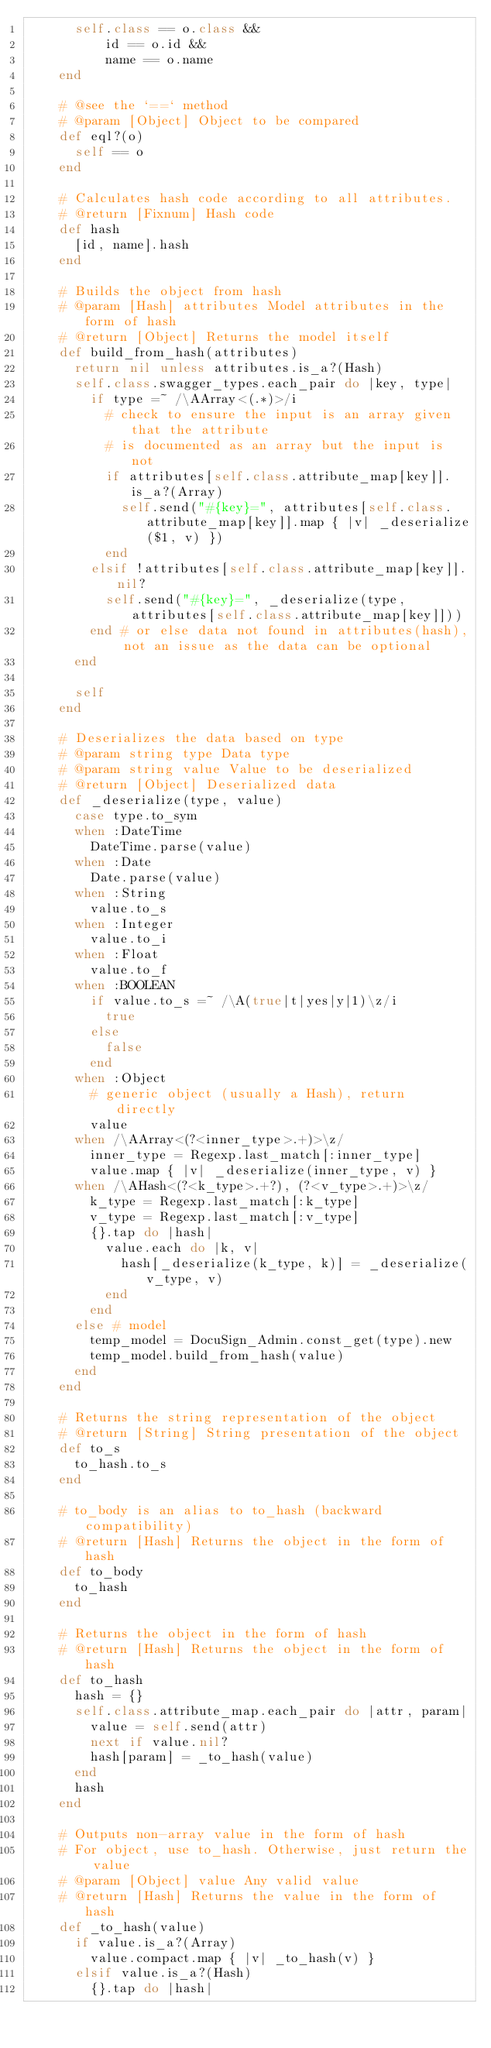Convert code to text. <code><loc_0><loc_0><loc_500><loc_500><_Ruby_>      self.class == o.class &&
          id == o.id &&
          name == o.name
    end

    # @see the `==` method
    # @param [Object] Object to be compared
    def eql?(o)
      self == o
    end

    # Calculates hash code according to all attributes.
    # @return [Fixnum] Hash code
    def hash
      [id, name].hash
    end

    # Builds the object from hash
    # @param [Hash] attributes Model attributes in the form of hash
    # @return [Object] Returns the model itself
    def build_from_hash(attributes)
      return nil unless attributes.is_a?(Hash)
      self.class.swagger_types.each_pair do |key, type|
        if type =~ /\AArray<(.*)>/i
          # check to ensure the input is an array given that the attribute
          # is documented as an array but the input is not
          if attributes[self.class.attribute_map[key]].is_a?(Array)
            self.send("#{key}=", attributes[self.class.attribute_map[key]].map { |v| _deserialize($1, v) })
          end
        elsif !attributes[self.class.attribute_map[key]].nil?
          self.send("#{key}=", _deserialize(type, attributes[self.class.attribute_map[key]]))
        end # or else data not found in attributes(hash), not an issue as the data can be optional
      end

      self
    end

    # Deserializes the data based on type
    # @param string type Data type
    # @param string value Value to be deserialized
    # @return [Object] Deserialized data
    def _deserialize(type, value)
      case type.to_sym
      when :DateTime
        DateTime.parse(value)
      when :Date
        Date.parse(value)
      when :String
        value.to_s
      when :Integer
        value.to_i
      when :Float
        value.to_f
      when :BOOLEAN
        if value.to_s =~ /\A(true|t|yes|y|1)\z/i
          true
        else
          false
        end
      when :Object
        # generic object (usually a Hash), return directly
        value
      when /\AArray<(?<inner_type>.+)>\z/
        inner_type = Regexp.last_match[:inner_type]
        value.map { |v| _deserialize(inner_type, v) }
      when /\AHash<(?<k_type>.+?), (?<v_type>.+)>\z/
        k_type = Regexp.last_match[:k_type]
        v_type = Regexp.last_match[:v_type]
        {}.tap do |hash|
          value.each do |k, v|
            hash[_deserialize(k_type, k)] = _deserialize(v_type, v)
          end
        end
      else # model
        temp_model = DocuSign_Admin.const_get(type).new
        temp_model.build_from_hash(value)
      end
    end

    # Returns the string representation of the object
    # @return [String] String presentation of the object
    def to_s
      to_hash.to_s
    end

    # to_body is an alias to to_hash (backward compatibility)
    # @return [Hash] Returns the object in the form of hash
    def to_body
      to_hash
    end

    # Returns the object in the form of hash
    # @return [Hash] Returns the object in the form of hash
    def to_hash
      hash = {}
      self.class.attribute_map.each_pair do |attr, param|
        value = self.send(attr)
        next if value.nil?
        hash[param] = _to_hash(value)
      end
      hash
    end

    # Outputs non-array value in the form of hash
    # For object, use to_hash. Otherwise, just return the value
    # @param [Object] value Any valid value
    # @return [Hash] Returns the value in the form of hash
    def _to_hash(value)
      if value.is_a?(Array)
        value.compact.map { |v| _to_hash(v) }
      elsif value.is_a?(Hash)
        {}.tap do |hash|</code> 